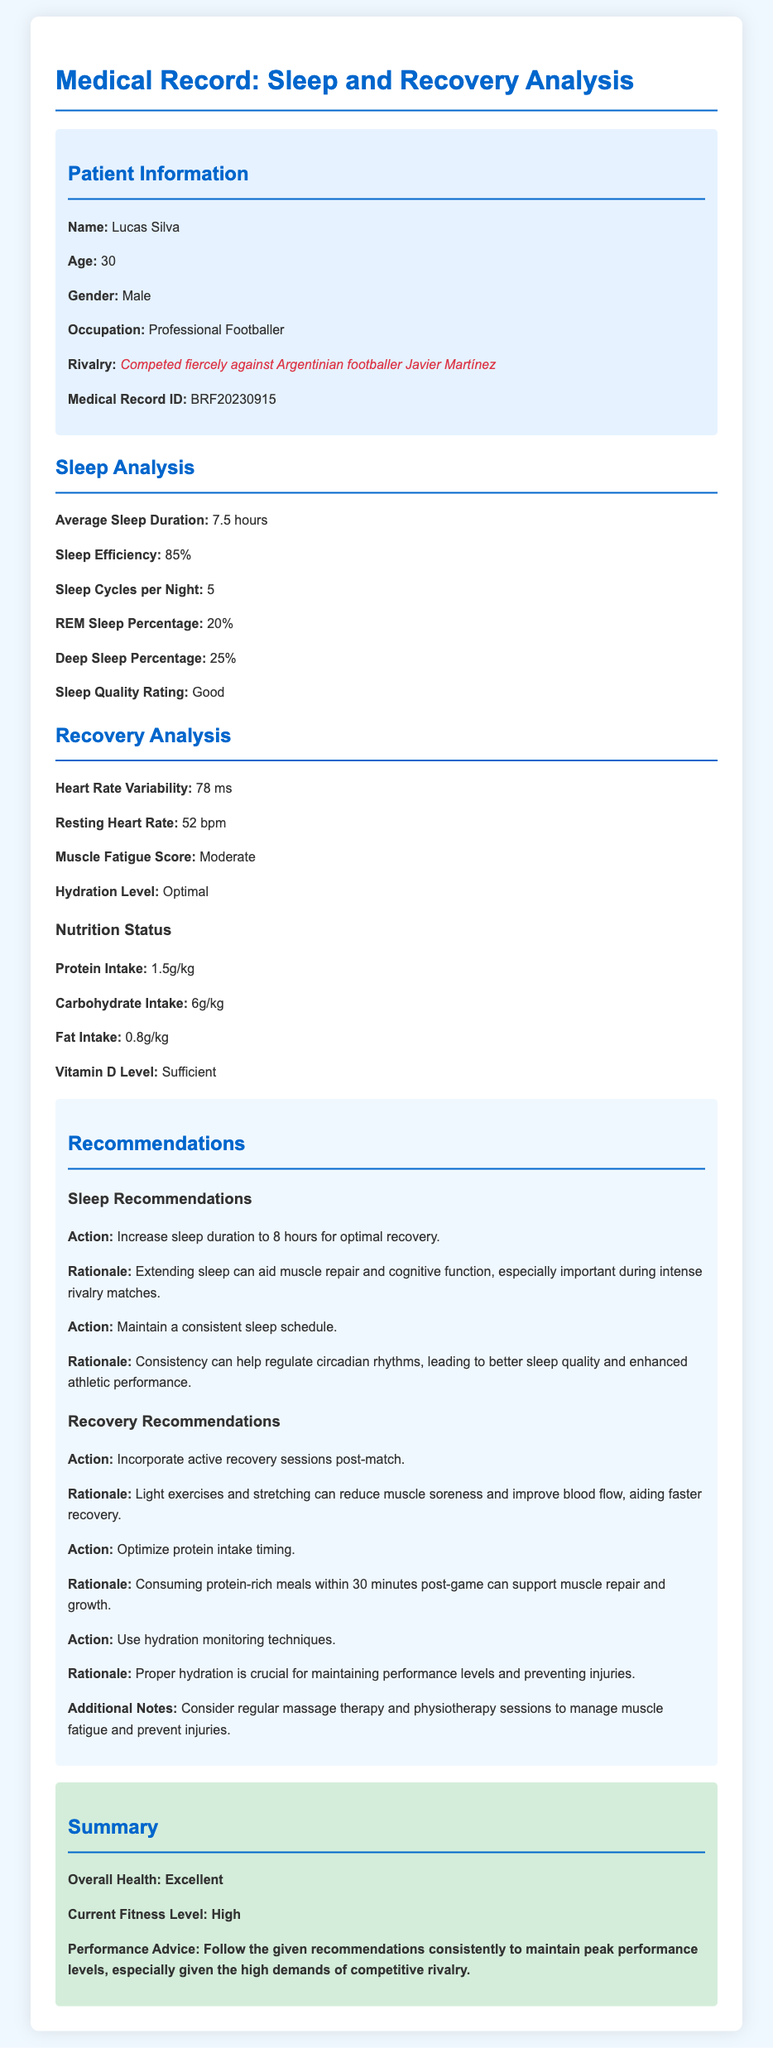What is the average sleep duration? The average sleep duration can be found under the Sleep Analysis section, which states 7.5 hours.
Answer: 7.5 hours What is the patient's age? The patient's age is mentioned in the Patient Information section, which states he is 30 years old.
Answer: 30 What is Lucas Silva's resting heart rate? The resting heart rate is presented in the Recovery Analysis section and is listed as 52 bpm.
Answer: 52 bpm What percentage of sleep is categorized as deep sleep? The deep sleep percentage is specified under Sleep Analysis, indicating it is 25%.
Answer: 25% What are the recommended protein intake timings? The recommendations include that protein-rich meals should be consumed within 30 minutes post-game for muscle repair, found in the Recovery Recommendations section.
Answer: Within 30 minutes post-game What hydration level is reported in the document? The document notes that the hydration level is optimal in the Recovery Analysis section.
Answer: Optimal What actions are suggested to improve sleep quality? The recommendations state to increase sleep duration to 8 hours and maintain a consistent sleep schedule for optimal recovery.
Answer: Increase sleep duration to 8 hours and maintain a consistent sleep schedule What is the heart rate variability value? The heart rate variability is specified in the Recovery Analysis section as 78 ms.
Answer: 78 ms What note is provided about additional recovery techniques? The additional notes suggest considering regular massage therapy and physiotherapy sessions to manage muscle fatigue and prevent injuries.
Answer: Consider regular massage therapy and physiotherapy sessions 